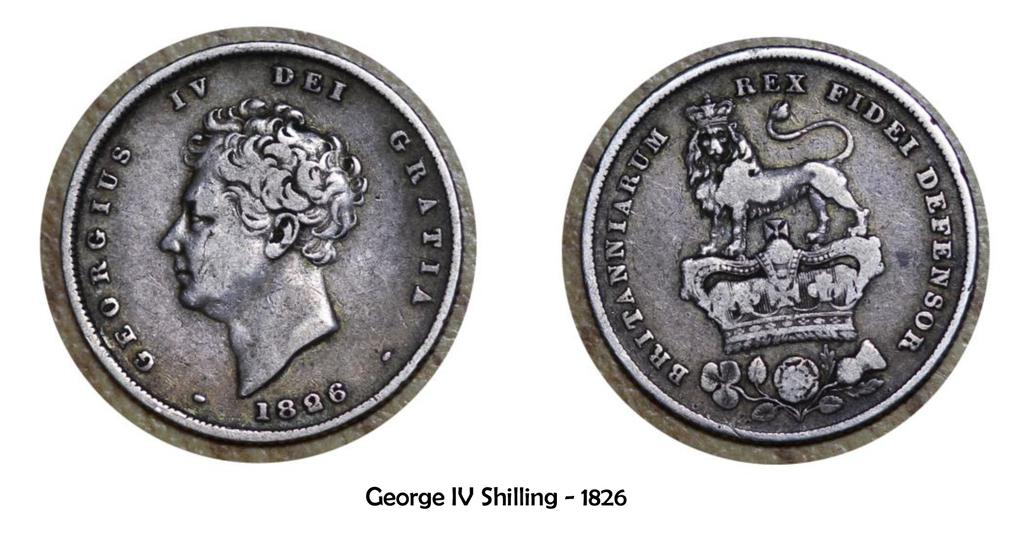Provide a one-sentence caption for the provided image. The front and back of a George IV Shilling from 1826. 